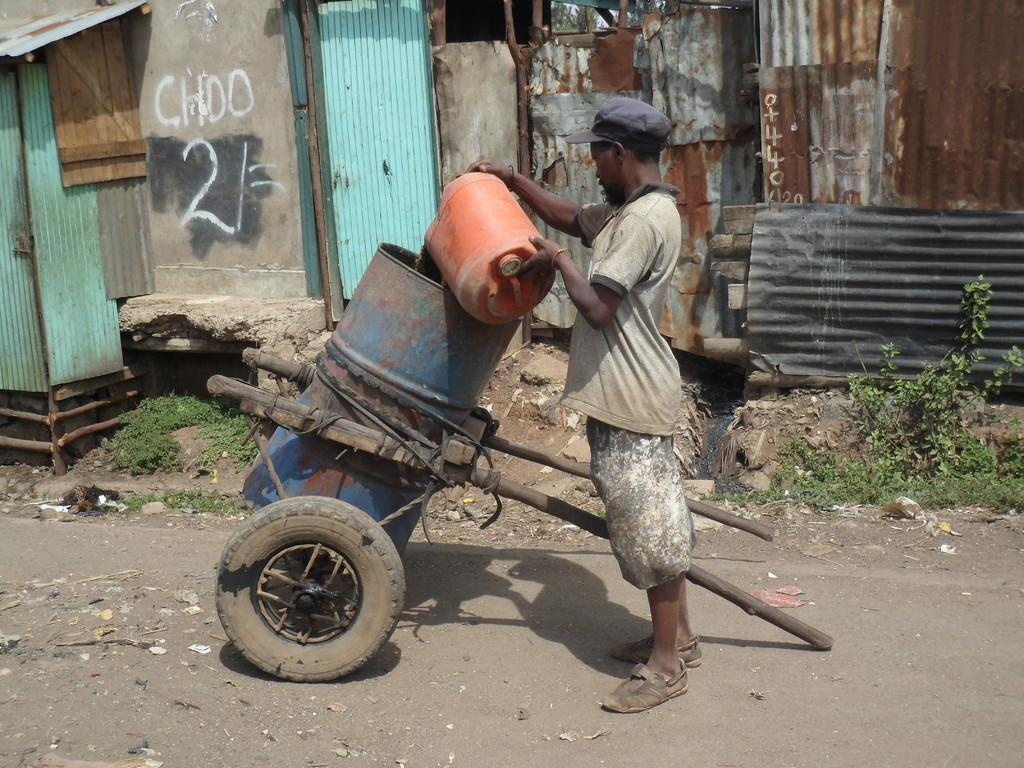Who is present in the image? There is a man in the image. Can you describe the man's clothing? The man is wearing worn clothes. What is the man holding in the image? The man is holding a barrel. What object is beside the man? There is a trolley beside the man. What can be seen on the background wall? There are iron sheets on the background wall. What time does the clock show in the image? There is no clock present in the image, so it is not possible to determine the time. 